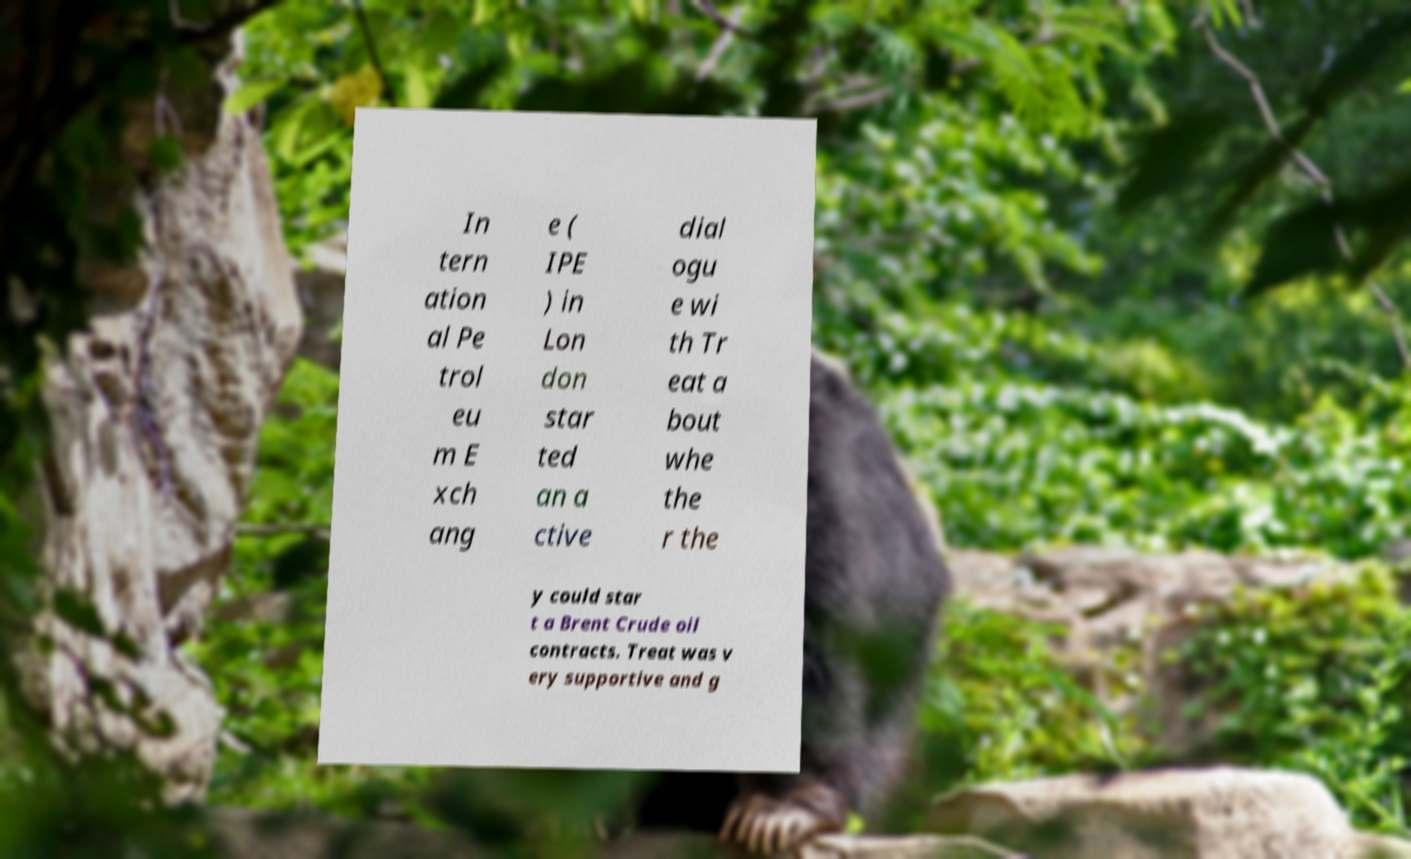Could you assist in decoding the text presented in this image and type it out clearly? In tern ation al Pe trol eu m E xch ang e ( IPE ) in Lon don star ted an a ctive dial ogu e wi th Tr eat a bout whe the r the y could star t a Brent Crude oil contracts. Treat was v ery supportive and g 